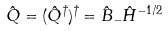Convert formula to latex. <formula><loc_0><loc_0><loc_500><loc_500>\hat { Q } = ( \hat { Q } ^ { \dagger } ) ^ { \dagger } = \hat { B } _ { - } \hat { H } ^ { - 1 / 2 }</formula> 